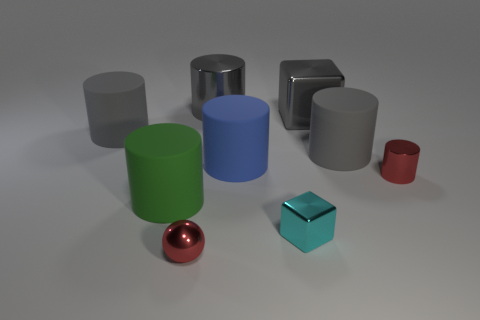Subtract all gray cylinders. How many were subtracted if there are1gray cylinders left? 2 Subtract all brown cubes. How many gray cylinders are left? 3 Subtract all green cylinders. How many cylinders are left? 5 Add 1 tiny blue rubber blocks. How many objects exist? 10 Subtract all tiny metal cylinders. How many cylinders are left? 5 Subtract all cubes. How many objects are left? 7 Add 7 tiny red cylinders. How many tiny red cylinders are left? 8 Add 3 blue shiny cylinders. How many blue shiny cylinders exist? 3 Subtract 0 blue blocks. How many objects are left? 9 Subtract all gray blocks. Subtract all cyan cylinders. How many blocks are left? 1 